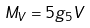Convert formula to latex. <formula><loc_0><loc_0><loc_500><loc_500>M _ { V } = 5 g _ { 5 } V</formula> 